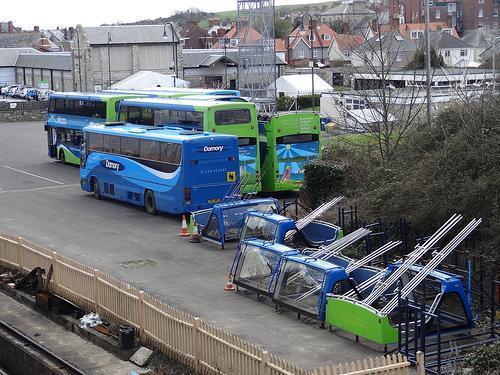How many people are visible?
Give a very brief answer. 0. 